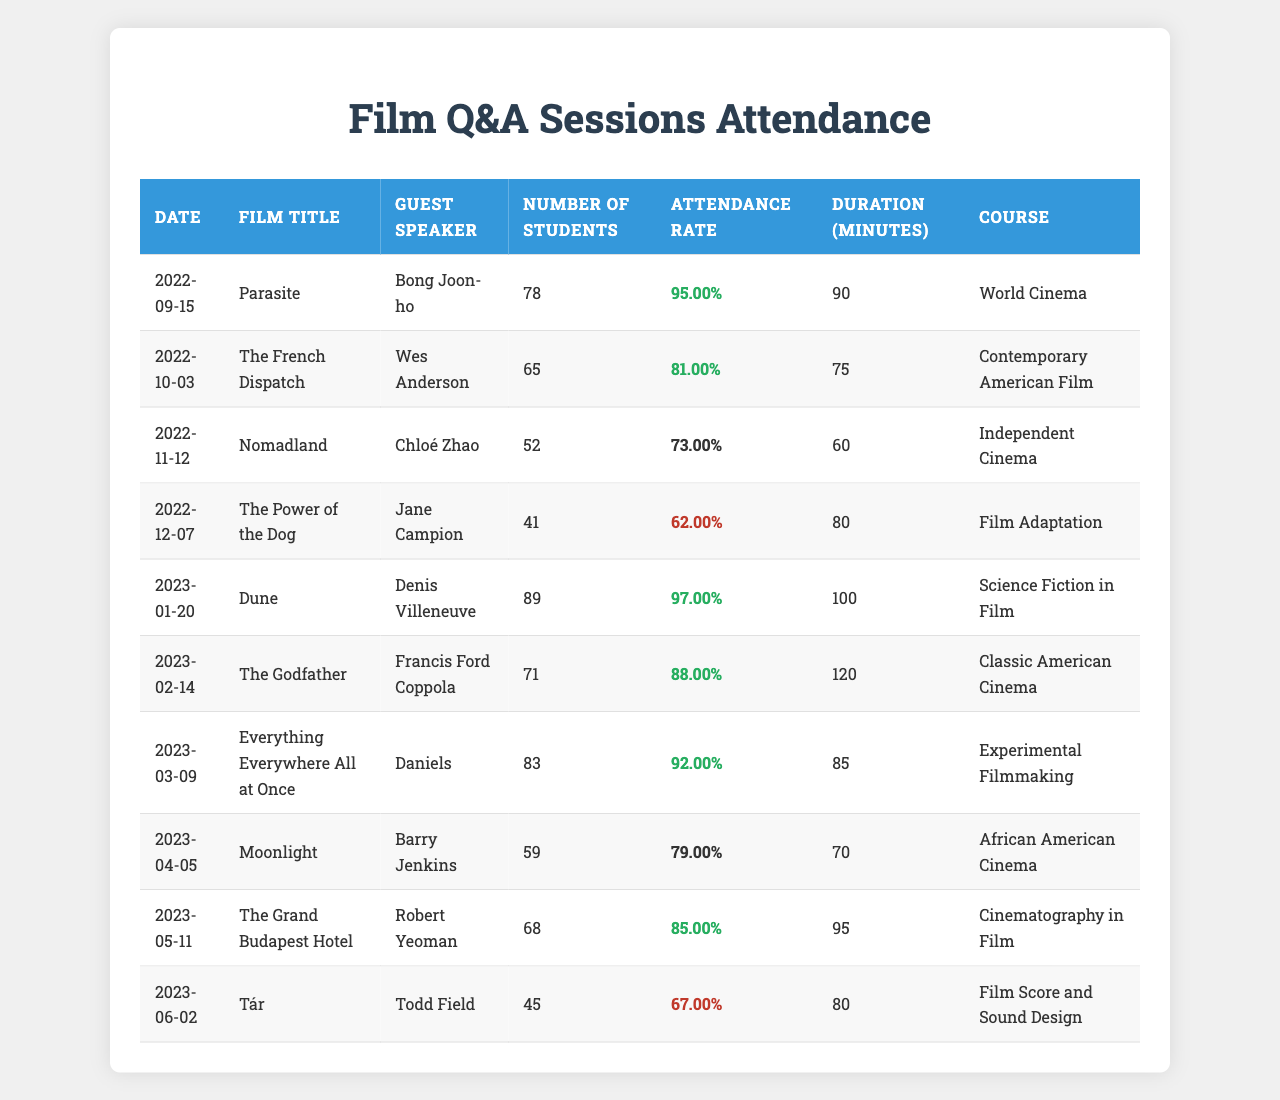What was the attendance rate for "Parasite"? The attendance rate for "Parasite," as shown in the table, is listed under the "Attendance Rate" column on the row corresponding to its date. It is 0.95.
Answer: 0.95 Which film had the lowest number of students in attendance? By reviewing the "Number of Students" column, I can see that "The Power of the Dog" has the lowest attendance with 41 students.
Answer: 41 What is the average attendance rate across all sessions? To find the average, I will sum all the attendance rates: (0.95 + 0.81 + 0.73 + 0.62 + 0.97 + 0.88 + 0.92 + 0.79 + 0.85 + 0.67) = 8.81, and then divide by the number of sessions (10): 8.81 / 10 = 0.881.
Answer: 0.881 Did "Dune" have a higher attendance rate than "The French Dispatch"? Comparing the two attendance rates directly from the table: "Dune" has an attendance rate of 0.97, while "The French Dispatch" has 0.81. Since 0.97 is greater than 0.81, the statement is true.
Answer: Yes What was the duration of "Everything Everywhere All at Once"? The duration is found in the "Duration (minutes)" column corresponding to that film's row. It indicates that the duration is 85 minutes.
Answer: 85 Which guest speaker had the highest attendance rate? I need to check the "Attendance Rate" column for each guest speaker's row and look for the highest value. "Dune" with Denis Villeneuve has the highest rate at 0.97.
Answer: Denis Villeneuve How many films had an attendance rate of less than 0.7? I examine the "Attendance Rate" column and count the number of entries that are less than 0.7. The films "Nomadland" (0.73) and "The Power of the Dog" (0.62) count as two, making it 2 films overall.
Answer: 2 Calculate the total number of students who attended all film Q&A sessions. I'll add the values in the "Number of Students" column together: 78 + 65 + 52 + 41 + 89 + 71 + 83 + 59 + 68 + 45 =  651.
Answer: 651 Which course had the highest attendance rate, and what was that rate? I will check the "Attendance Rate" for each course and find the maximum. The course "Science Fiction in Film" for "Dune" had the highest attendance rate of 0.97.
Answer: Science Fiction in Film, 0.97 What is the difference in student attendance between "Nomadland" and "Moonlight"? To find the difference, I subtract the attendance of "Moonlight" (59) from "Nomadland" (52): 52 - 59 = -7. This means "Moonlight" had 7 more students.
Answer: -7 Which two films had attendance rates above 0.8? Looking at the "Attendance Rate" column, the films "Parasite" (0.95) and "Dune" (0.97) both have rates above 0.8.
Answer: "Parasite" and "Dune" 